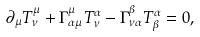<formula> <loc_0><loc_0><loc_500><loc_500>\partial _ { \mu } T ^ { \mu } _ { \nu } + \Gamma _ { \alpha \mu } ^ { \mu } T ^ { \alpha } _ { \nu } - \Gamma _ { \nu \alpha } ^ { \beta } T ^ { \alpha } _ { \beta } = 0 ,</formula> 